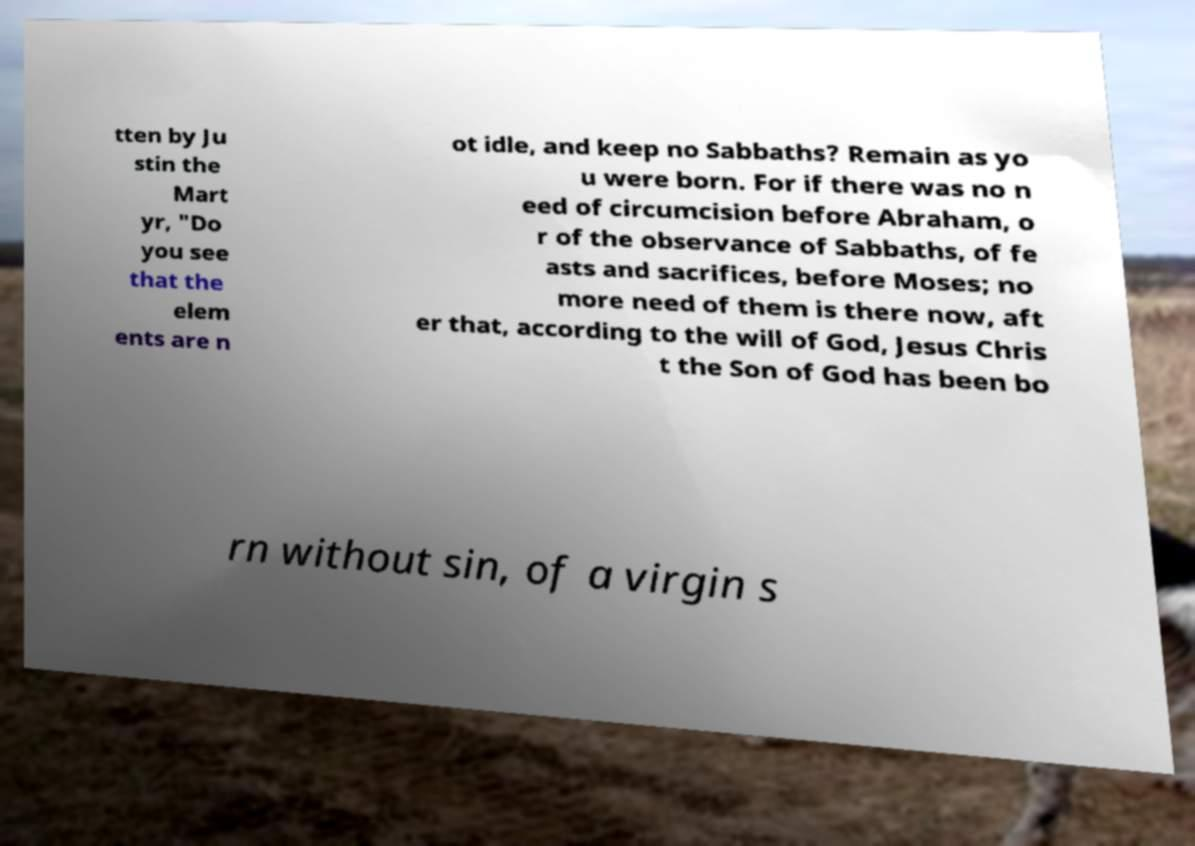What messages or text are displayed in this image? I need them in a readable, typed format. tten by Ju stin the Mart yr, "Do you see that the elem ents are n ot idle, and keep no Sabbaths? Remain as yo u were born. For if there was no n eed of circumcision before Abraham, o r of the observance of Sabbaths, of fe asts and sacrifices, before Moses; no more need of them is there now, aft er that, according to the will of God, Jesus Chris t the Son of God has been bo rn without sin, of a virgin s 